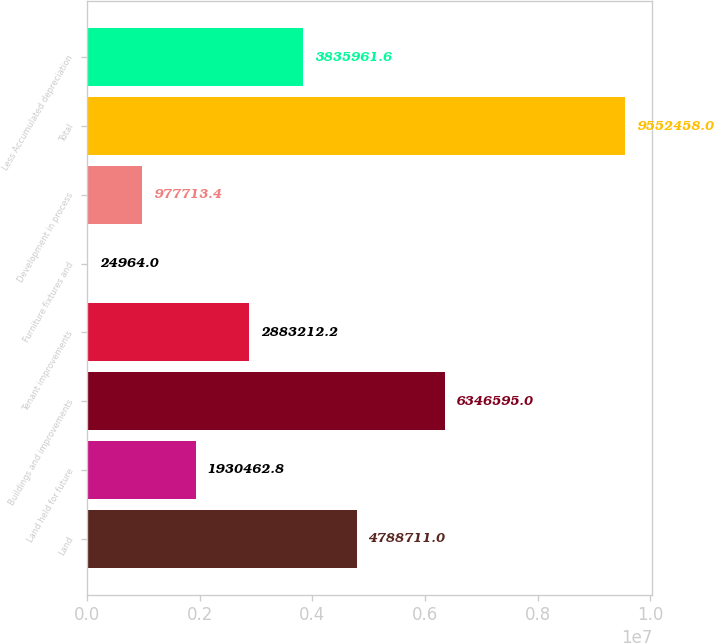Convert chart. <chart><loc_0><loc_0><loc_500><loc_500><bar_chart><fcel>Land<fcel>Land held for future<fcel>Buildings and improvements<fcel>Tenant improvements<fcel>Furniture fixtures and<fcel>Development in process<fcel>Total<fcel>Less Accumulated depreciation<nl><fcel>4.78871e+06<fcel>1.93046e+06<fcel>6.3466e+06<fcel>2.88321e+06<fcel>24964<fcel>977713<fcel>9.55246e+06<fcel>3.83596e+06<nl></chart> 